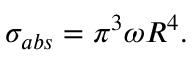Convert formula to latex. <formula><loc_0><loc_0><loc_500><loc_500>\sigma _ { a b s } = \pi ^ { 3 } \omega R ^ { 4 } .</formula> 